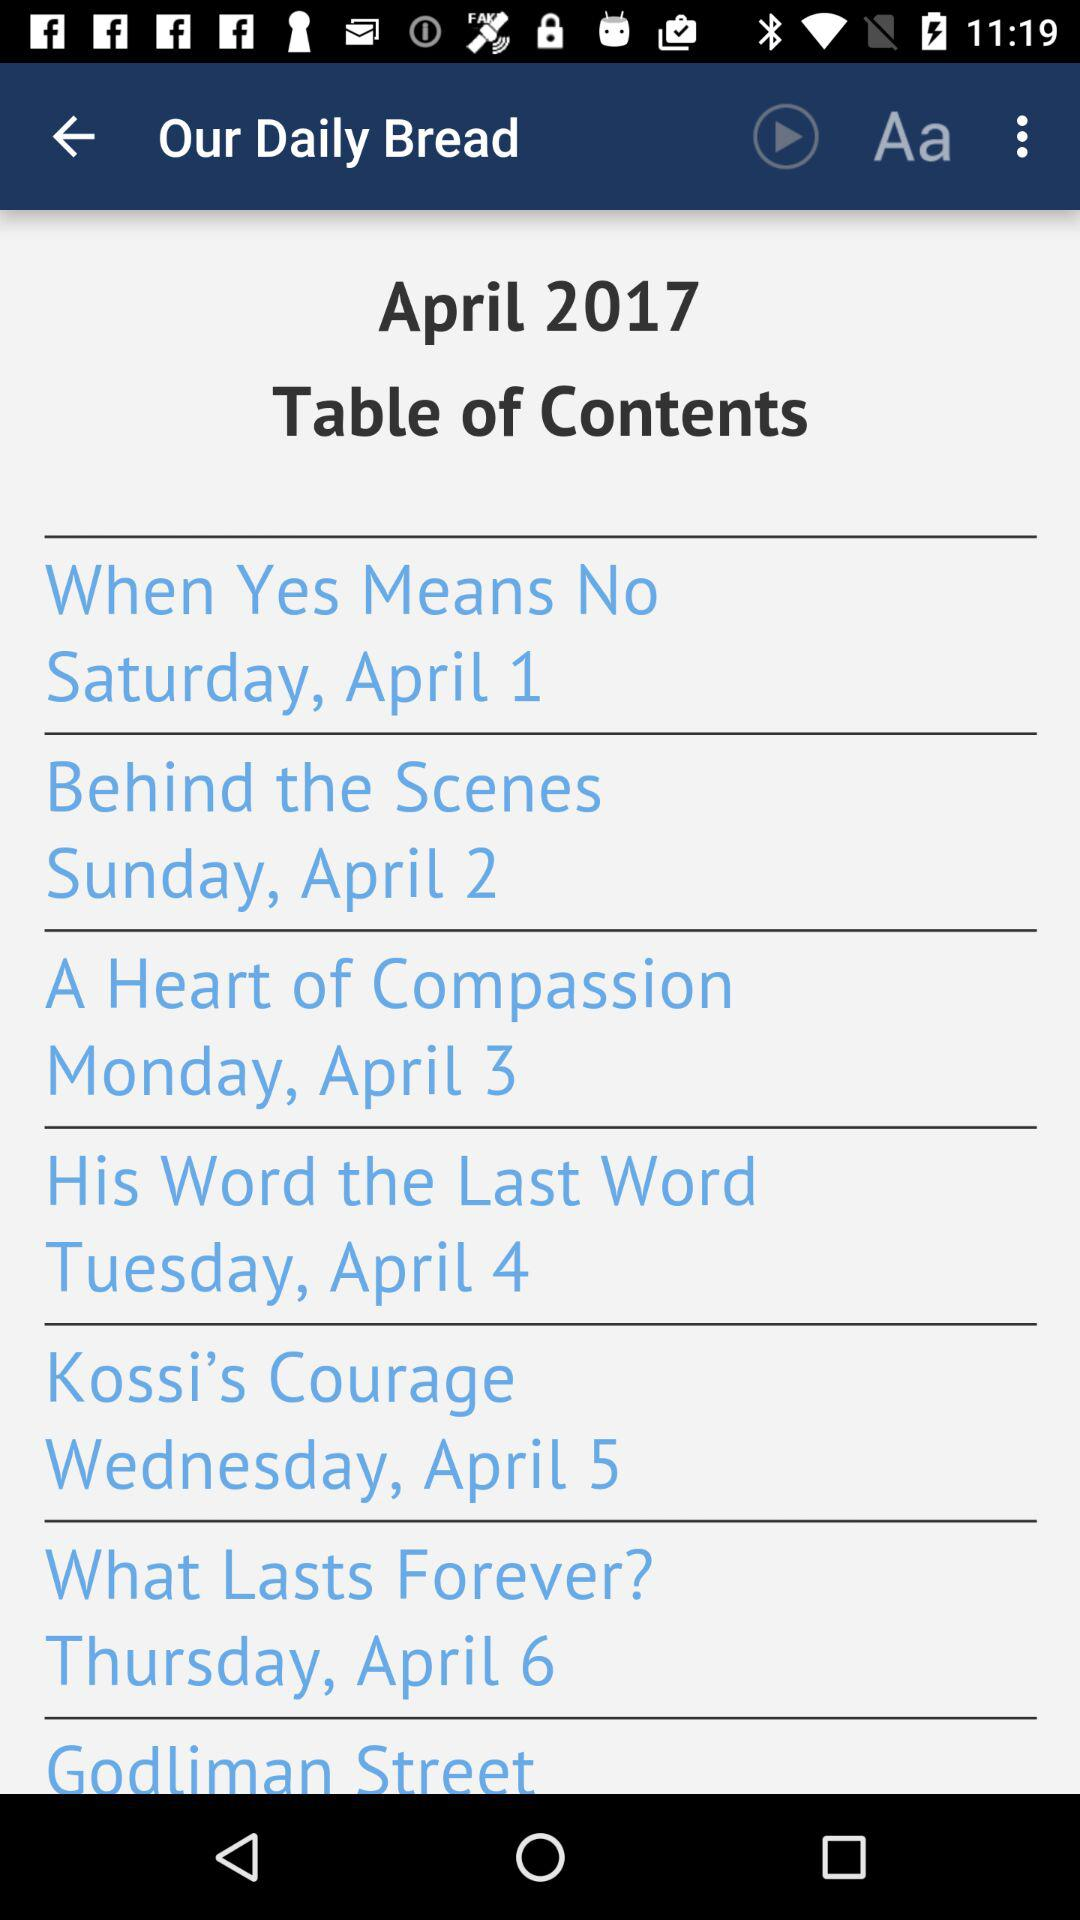What is the day mentioned under the article "Kossi's Courage"? The day mentioned under the article "Kossi's Courage" is Wednesday. 